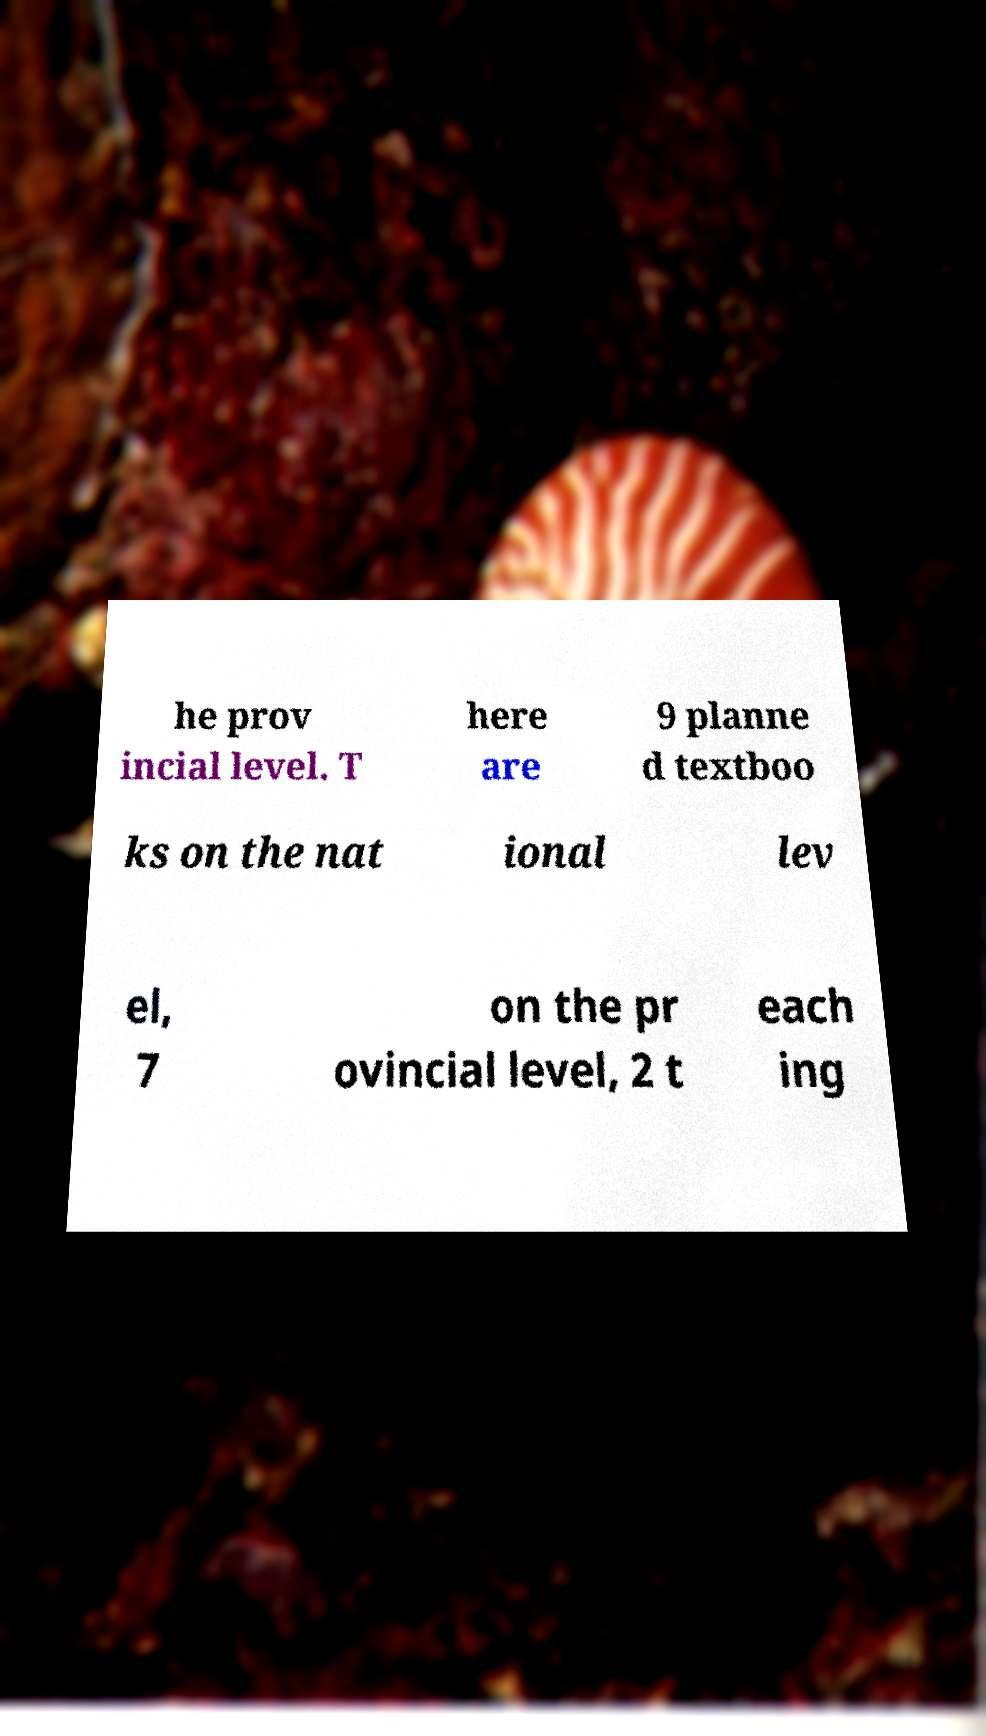Could you extract and type out the text from this image? he prov incial level. T here are 9 planne d textboo ks on the nat ional lev el, 7 on the pr ovincial level, 2 t each ing 